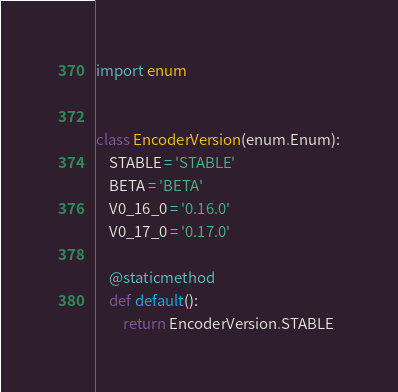Convert code to text. <code><loc_0><loc_0><loc_500><loc_500><_Python_>import enum


class EncoderVersion(enum.Enum):
    STABLE = 'STABLE'
    BETA = 'BETA'
    V0_16_0 = '0.16.0'
    V0_17_0 = '0.17.0'

    @staticmethod
    def default():
        return EncoderVersion.STABLE
</code> 